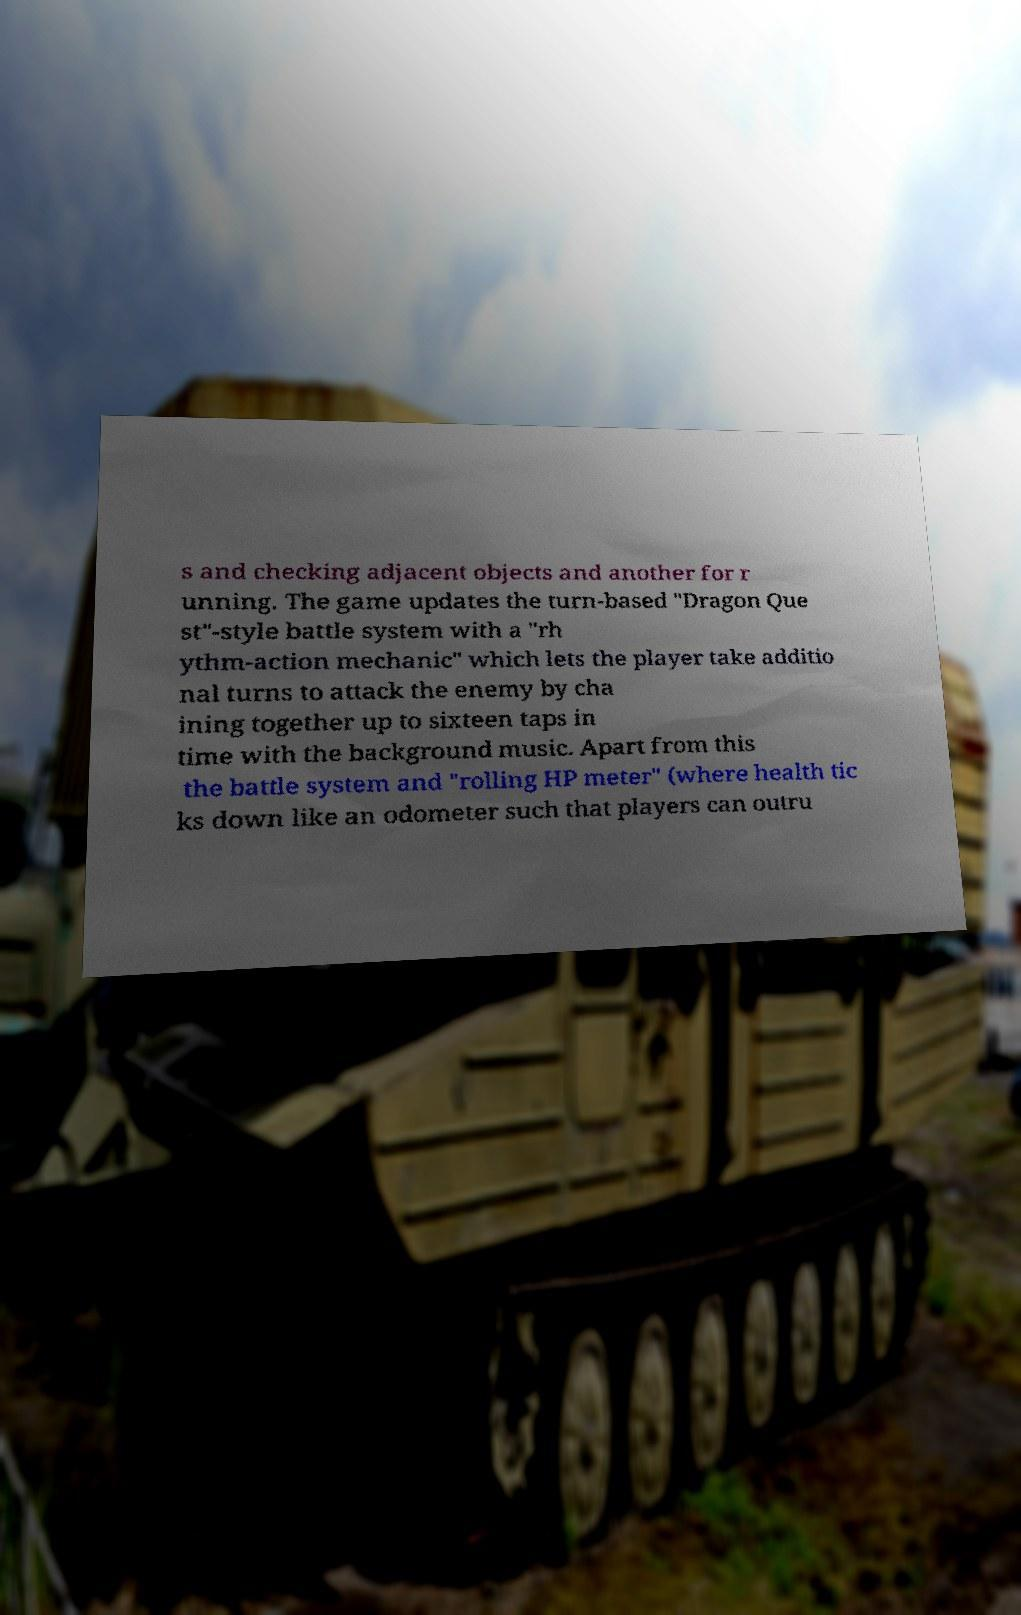Can you accurately transcribe the text from the provided image for me? s and checking adjacent objects and another for r unning. The game updates the turn-based "Dragon Que st"-style battle system with a "rh ythm-action mechanic" which lets the player take additio nal turns to attack the enemy by cha ining together up to sixteen taps in time with the background music. Apart from this the battle system and "rolling HP meter" (where health tic ks down like an odometer such that players can outru 